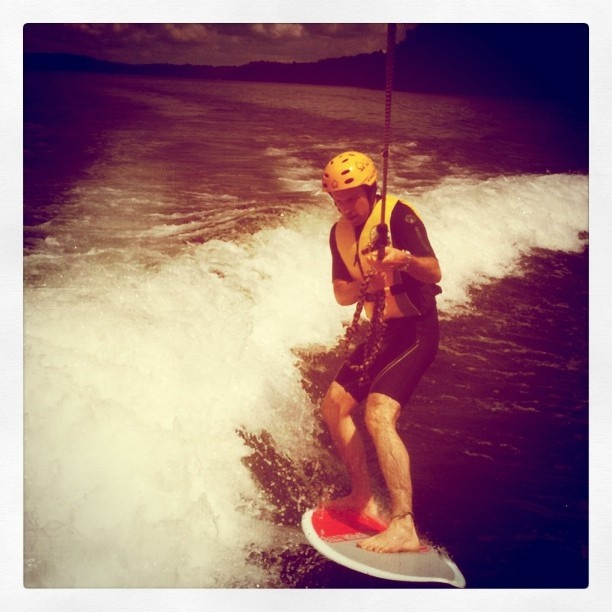Describe the objects in this image and their specific colors. I can see people in whitesmoke, purple, brown, tan, and salmon tones and surfboard in whitesmoke, tan, and beige tones in this image. 